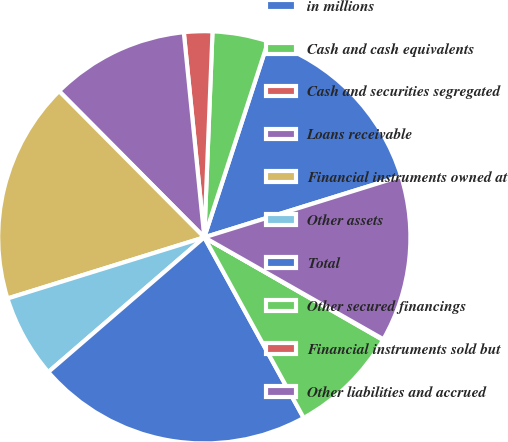Convert chart. <chart><loc_0><loc_0><loc_500><loc_500><pie_chart><fcel>in millions<fcel>Cash and cash equivalents<fcel>Cash and securities segregated<fcel>Loans receivable<fcel>Financial instruments owned at<fcel>Other assets<fcel>Total<fcel>Other secured financings<fcel>Financial instruments sold but<fcel>Other liabilities and accrued<nl><fcel>15.19%<fcel>4.38%<fcel>2.22%<fcel>10.86%<fcel>17.35%<fcel>6.54%<fcel>21.67%<fcel>8.7%<fcel>0.06%<fcel>13.03%<nl></chart> 